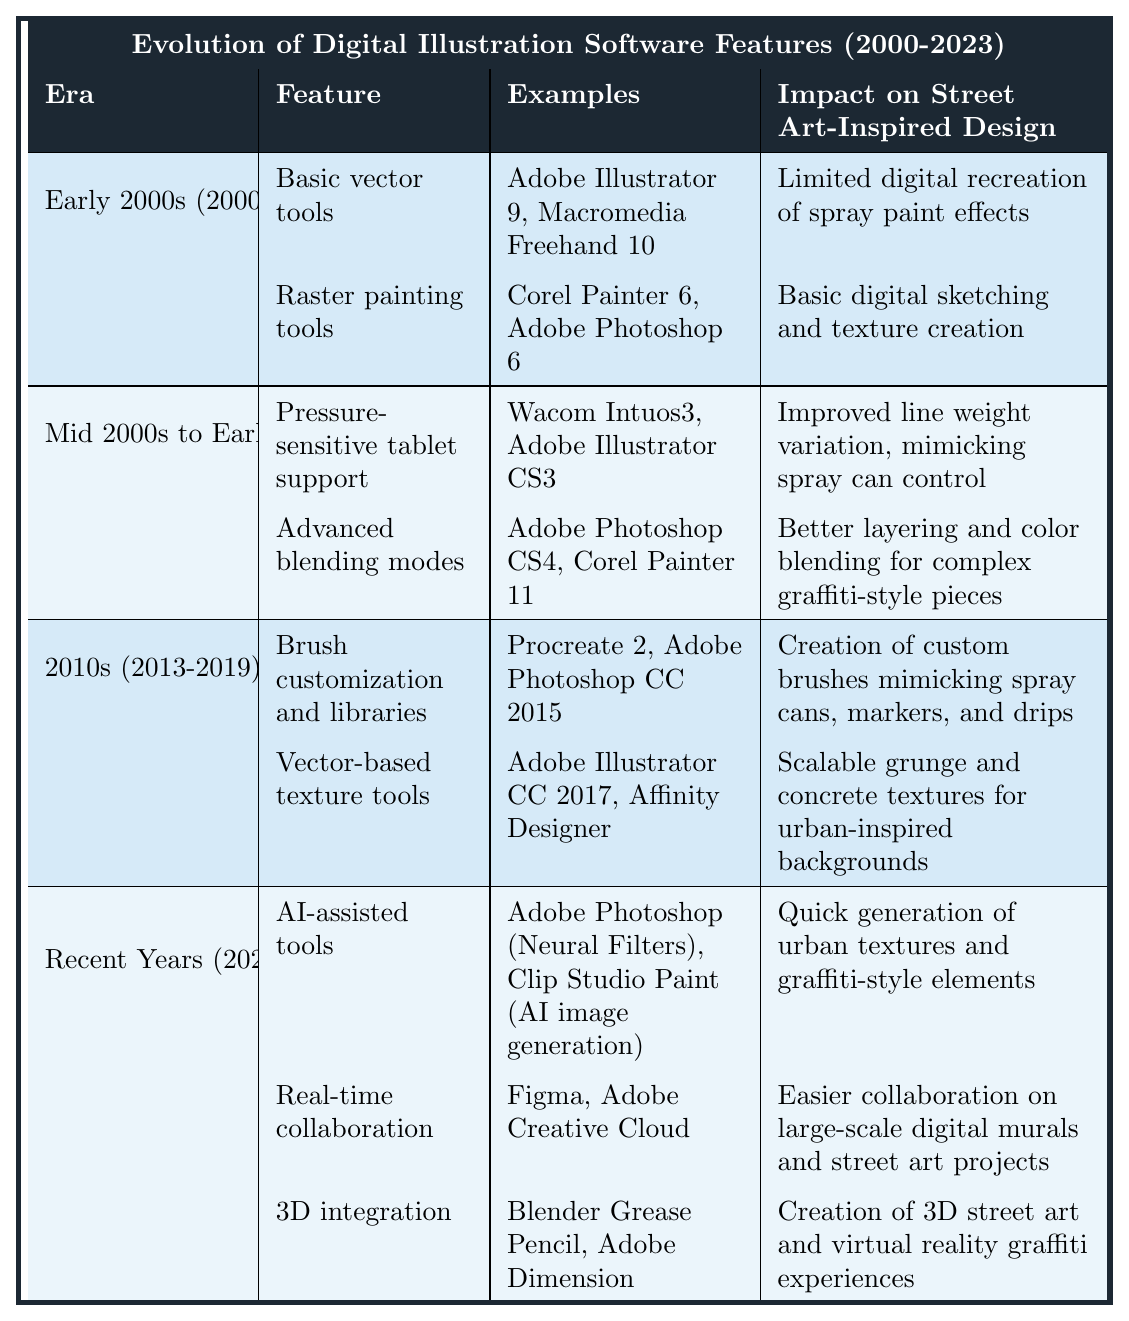What features were introduced in the Early 2000s? The Early 2000s introduced two main features: Basic vector tools and Raster painting tools. These features are listed in the table under that era.
Answer: Basic vector tools and Raster painting tools Which software examples were associated with advanced blending modes? The advanced blending modes feature is associated with Adobe Photoshop CS4 and Corel Painter 11, as indicated in the table.
Answer: Adobe Photoshop CS4 and Corel Painter 11 True or False: Real-time collaboration is a feature from the Mid 2000s to Early 2010s. The table lists real-time collaboration under the Recent Years (2020-2023) era, making the statement false.
Answer: False What impact did pressure-sensitive tablet support have on street art-inspired design? The table states that pressure-sensitive tablet support improved line weight variation, mimicking spray can control, which enhances the ability to create street art.
Answer: Improved line weight variation, mimicking spray can control Which feature from the 2010s allows the creation of custom brushes? The feature that allows the creation of custom brushes is "Brush customization and libraries," as stated in the table.
Answer: Brush customization and libraries How many features were introduced in the Recent Years (2020-2023)? The table shows three features introduced in the Recent Years: AI-assisted tools, Real-time collaboration, and 3D integration. Adding these gives a count of three.
Answer: Three Which era showcased improvement in layering and color blending for graffiti-style pieces? The Mid 2000s to Early 2010s era featured advanced blending modes, which improved layering and color blending for complex graffiti-style pieces.
Answer: Mid 2000s to Early 2010s What was the main impact of AI-assisted tools on street art-inspired design? The table indicates that AI-assisted tools allowed for the quick generation of urban textures and graffiti-style elements, benefiting street art design.
Answer: Quick generation of urban textures and graffiti-style elements Which software advancements relate to the use of 3D in street art? The feature related to 3D integration is highlighted in the Recent Years (2020-2023) section, specifically mentioning Blender Grease Pencil and Adobe Dimension.
Answer: Blender Grease Pencil and Adobe Dimension Is there a notable change in design capabilities from the Early 2000s to Recent Years? Yes, the table shows a significant advancement in the features available from basic tools to sophisticated AI-assisted tools and real-time collaboration, reflecting vast improvements in capabilities.
Answer: Yes 